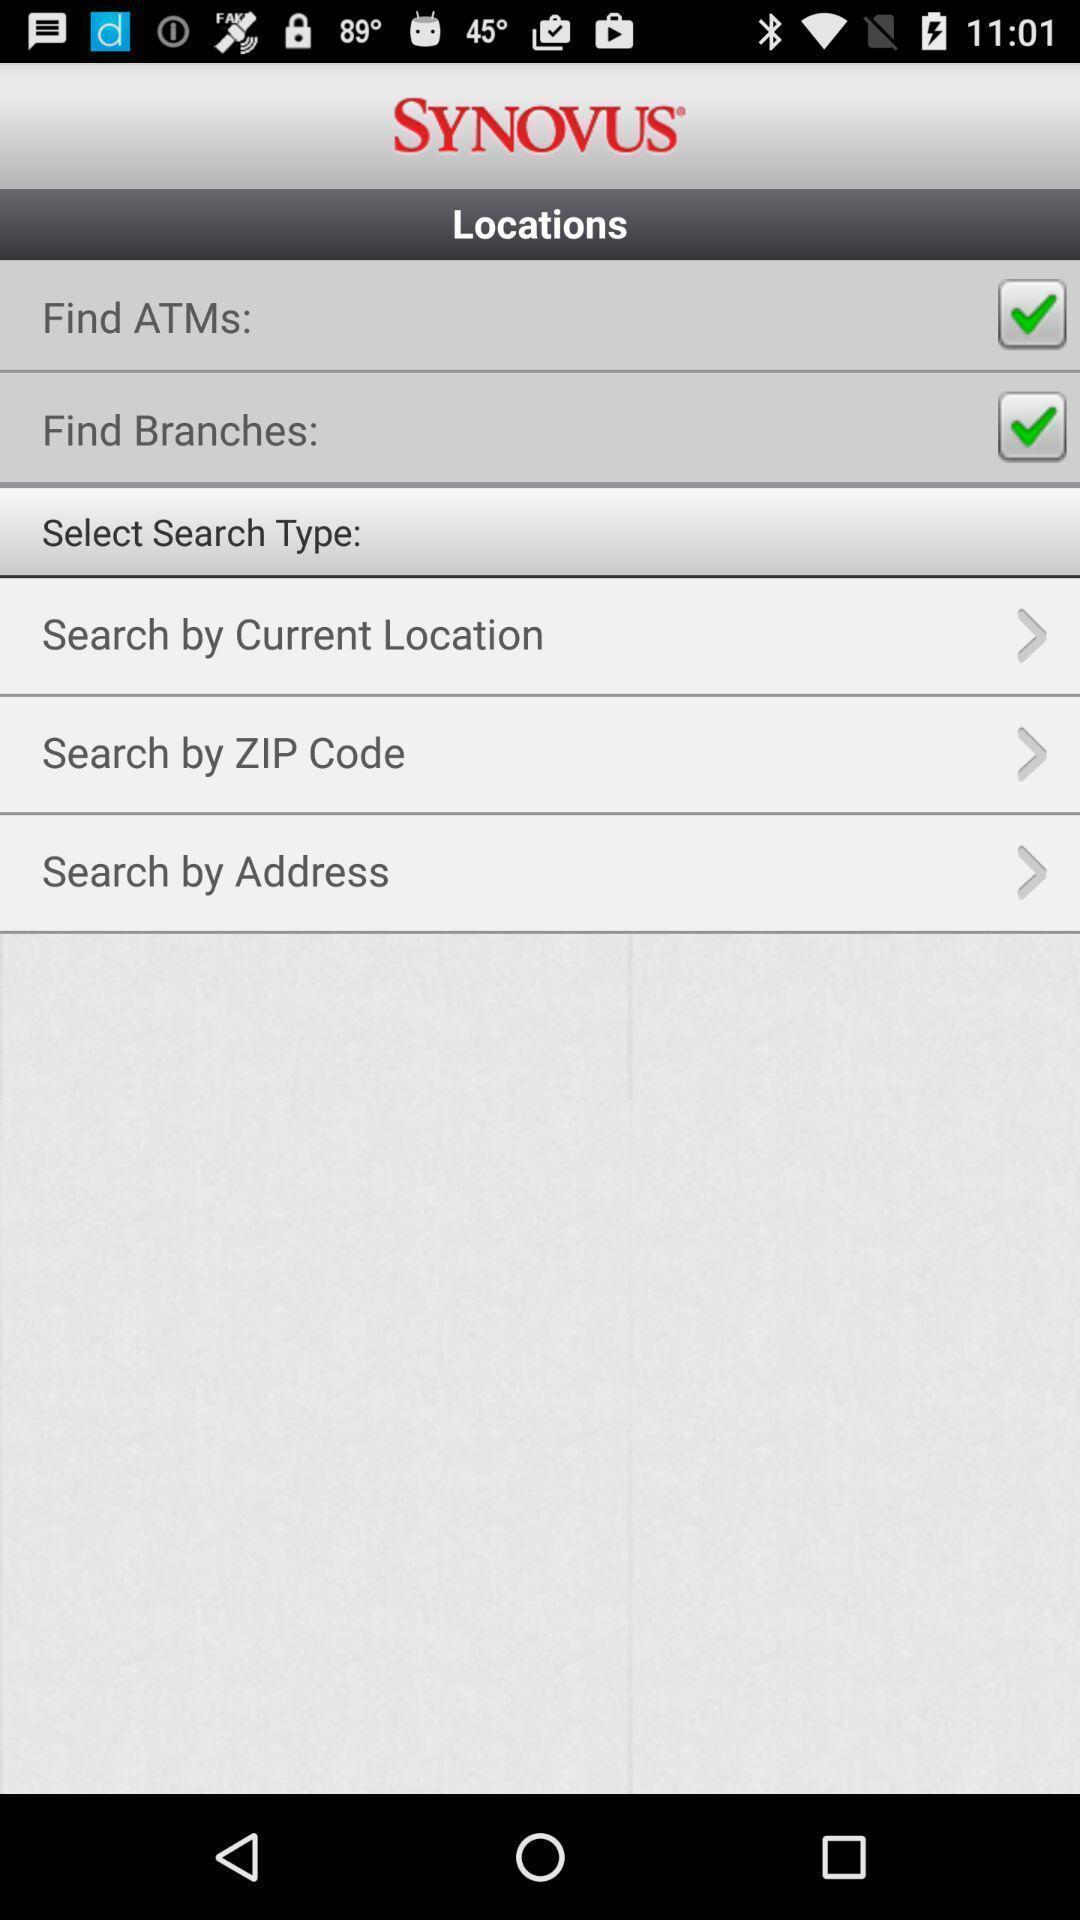Describe the content in this image. Screen displaying several options. 